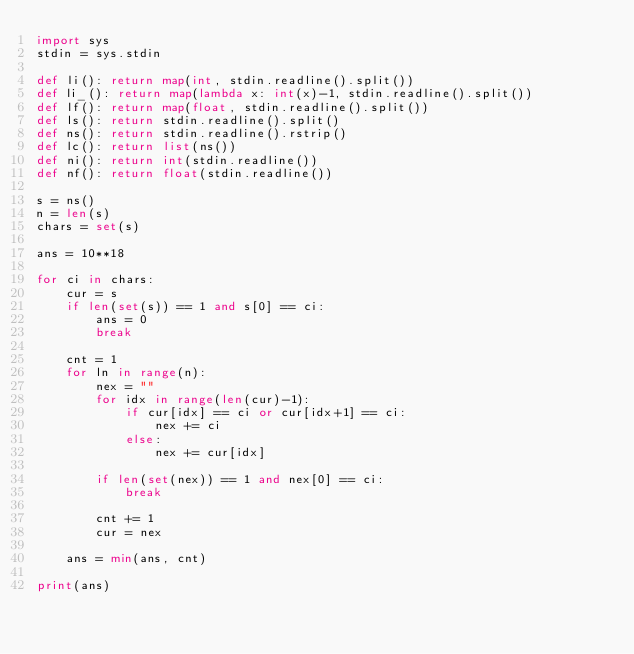<code> <loc_0><loc_0><loc_500><loc_500><_Python_>import sys
stdin = sys.stdin

def li(): return map(int, stdin.readline().split())
def li_(): return map(lambda x: int(x)-1, stdin.readline().split())
def lf(): return map(float, stdin.readline().split())
def ls(): return stdin.readline().split()
def ns(): return stdin.readline().rstrip()
def lc(): return list(ns())
def ni(): return int(stdin.readline())
def nf(): return float(stdin.readline())

s = ns()
n = len(s)
chars = set(s)

ans = 10**18

for ci in chars:
    cur = s
    if len(set(s)) == 1 and s[0] == ci:
        ans = 0
        break
    
    cnt = 1
    for ln in range(n):
        nex = ""
        for idx in range(len(cur)-1):
            if cur[idx] == ci or cur[idx+1] == ci:
                nex += ci
            else:
                nex += cur[idx]
                
        if len(set(nex)) == 1 and nex[0] == ci:
            break
        
        cnt += 1
        cur = nex
        
    ans = min(ans, cnt)
        
print(ans)</code> 